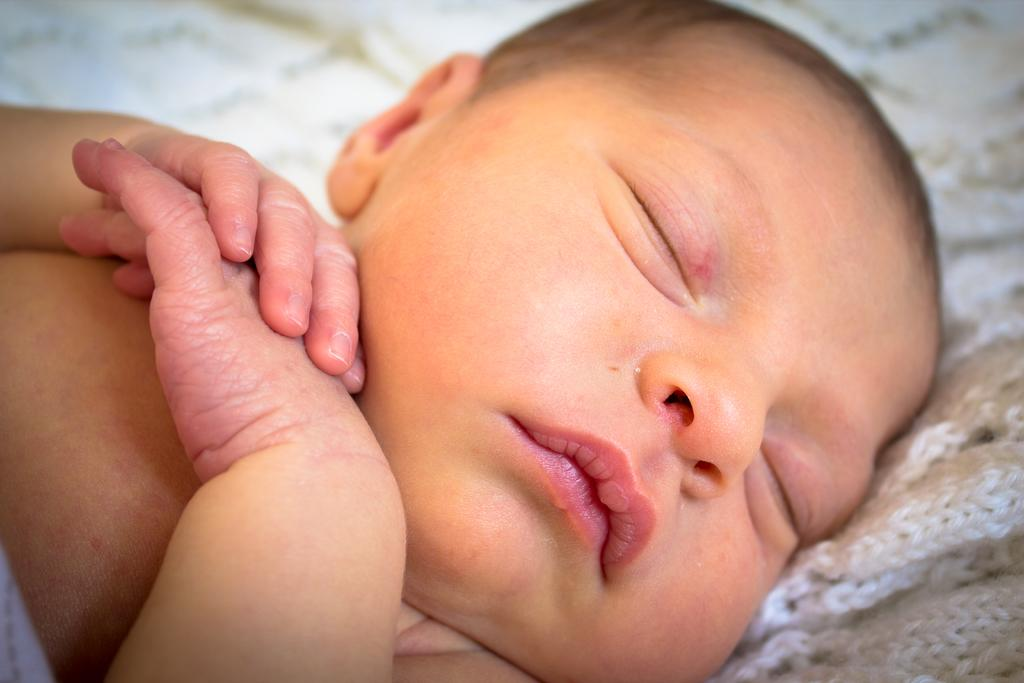What is the main subject of the image? The main subject of the image is a baby. What is the baby doing in the image? The baby is sleeping. What can be seen in the left corner of the image? There is a white blanket in the left corner of the image. What type of chair is the baby sitting on in the image? There is no chair present in the image; the baby is sleeping. Can you see a blade in the image? There is no blade present in the image. 